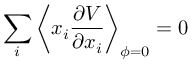Convert formula to latex. <formula><loc_0><loc_0><loc_500><loc_500>\sum _ { i } { \left \langle x _ { i } \frac { \partial V } { \partial x _ { i } } \right \rangle } _ { \phi = 0 } = 0</formula> 